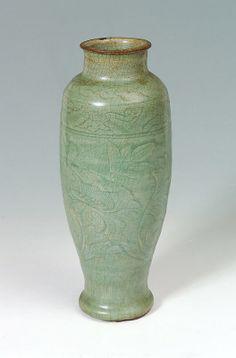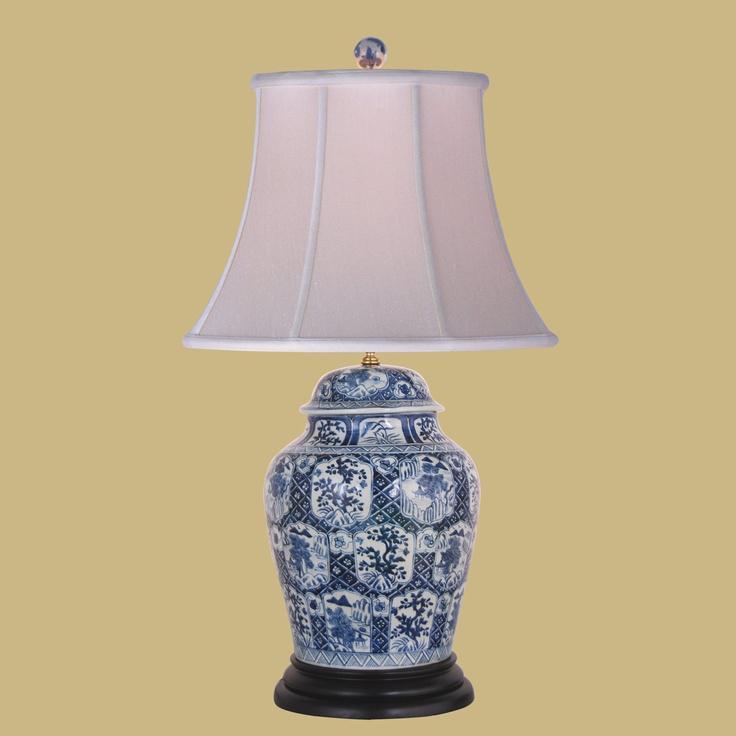The first image is the image on the left, the second image is the image on the right. Given the left and right images, does the statement "All ceramic objects are jade green, and at least one has a crackle finish, and at least one flares out at the top." hold true? Answer yes or no. No. The first image is the image on the left, the second image is the image on the right. Considering the images on both sides, is "At least one of the lamps shown features a shiny brass base." valid? Answer yes or no. No. 